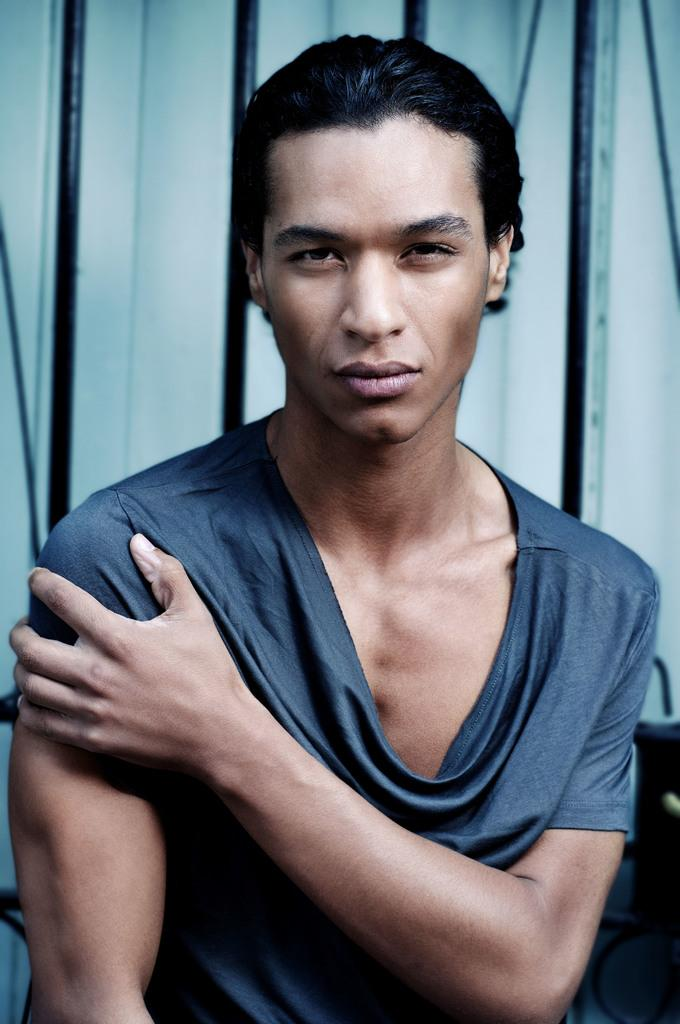What is the main subject of the image? The main subject of the image is a man. What is the man wearing in the image? The man is wearing a t-shirt in the image. What is the current weight of the man in the image? The image does not provide information about the man's weight, so it cannot be determined from the image. 